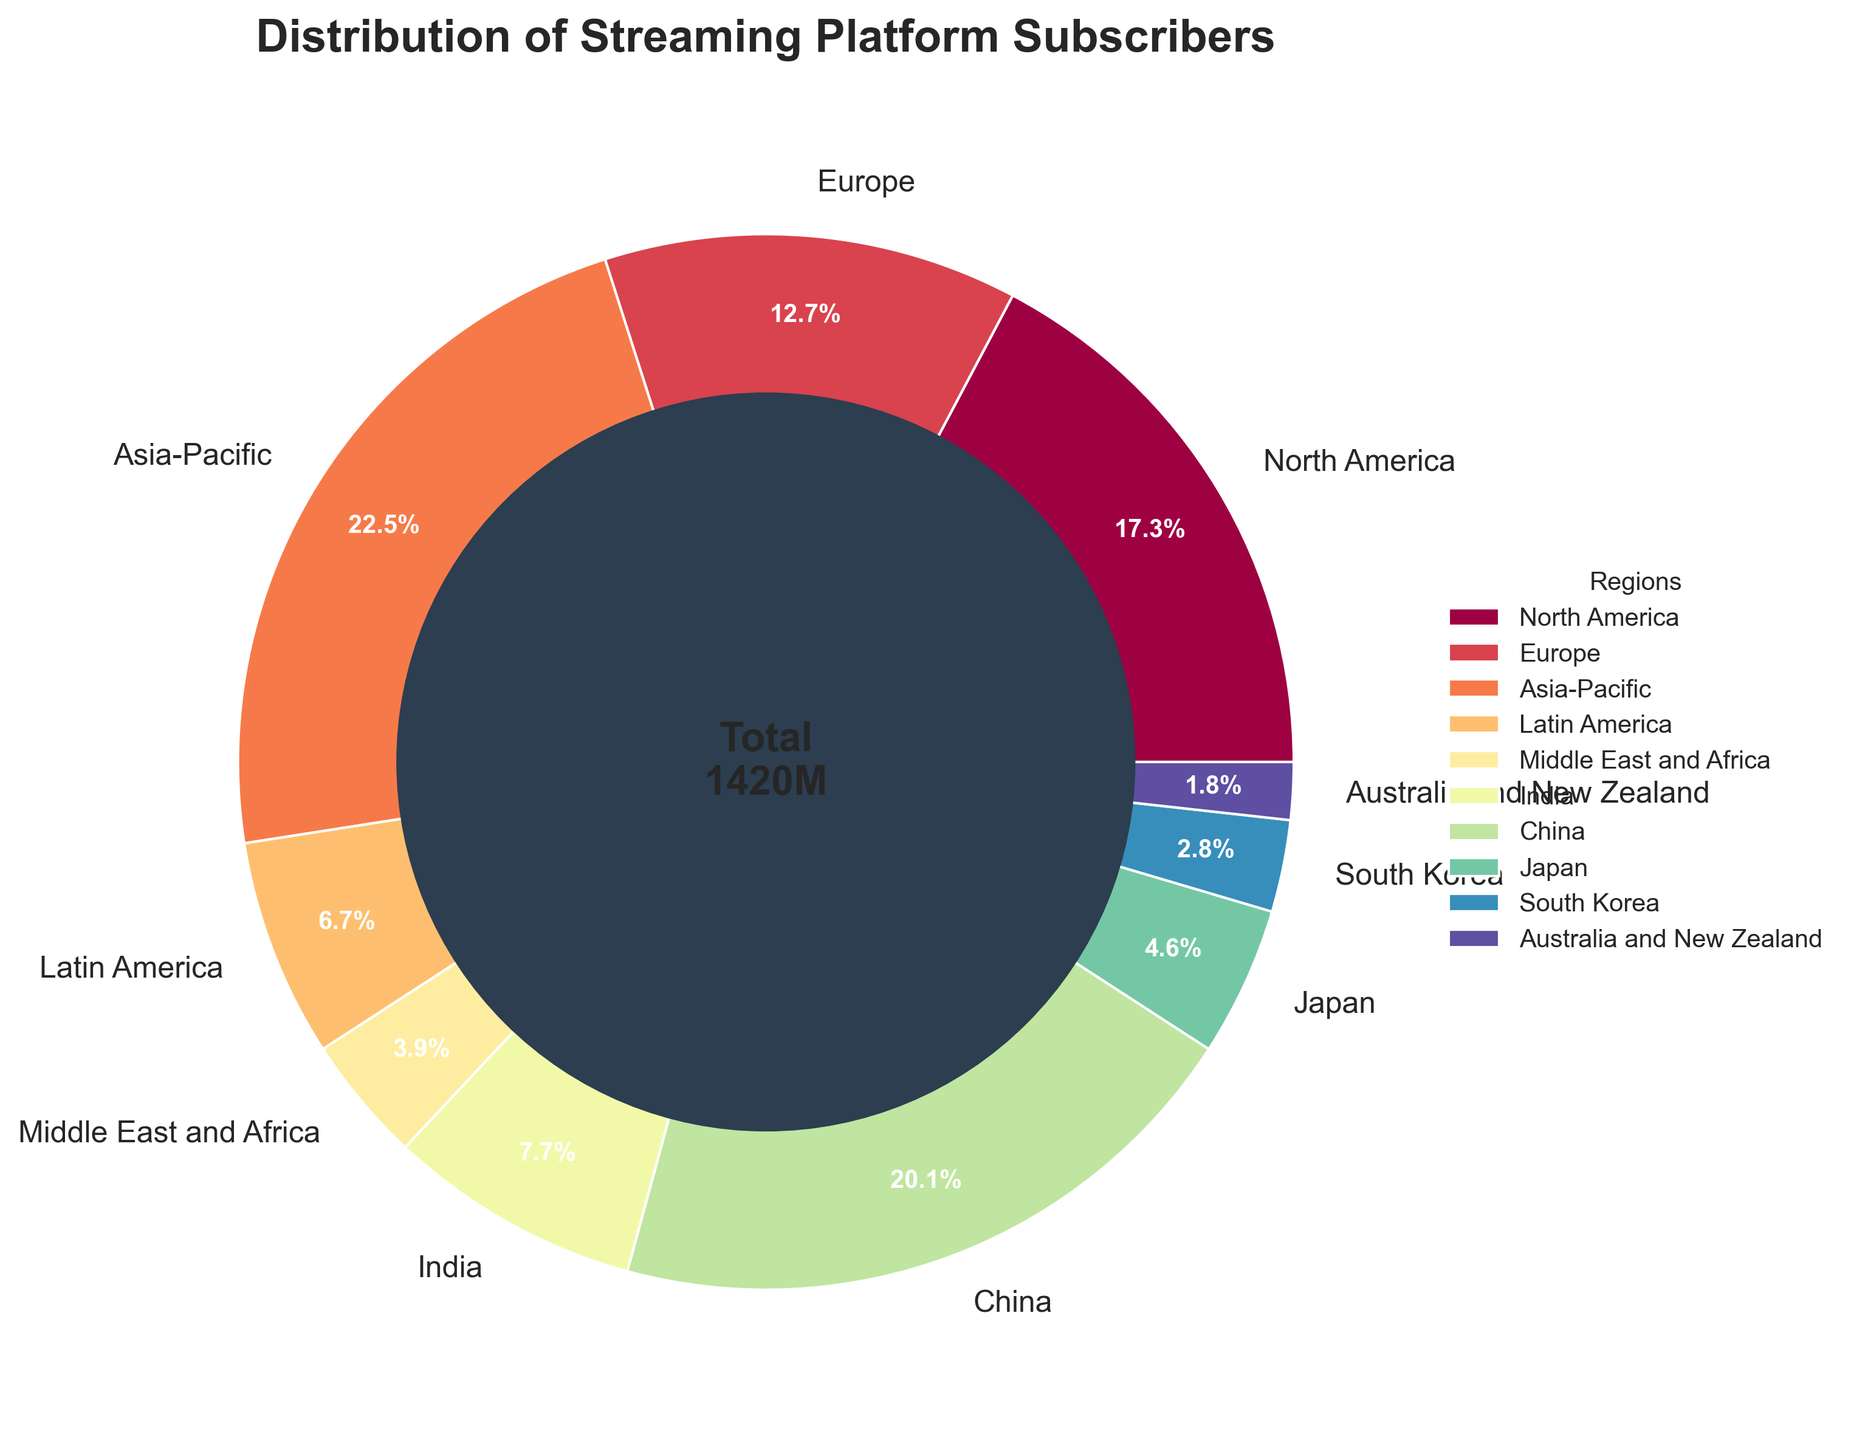What's the total number of streaming platform subscribers in North America and Europe? Summing the subscribers from North America and Europe: 245 million (North America) + 180 million (Europe) = 425 million
Answer: 425 million Which region has more subscribers, China or India? Comparing the subscribers between China and India, China has 285 million while India has 110 million. Hence, China has more subscribers.
Answer: China What percentage of global subscribers is from the Asia-Pacific region? The figure shows 'Asia-Pacific: 320 million subscribers'. The total subscribers are 1420 million. The percentage is (320/1420) * 100 ≈ 22.5%.
Answer: 22.5% Arrange the following regions in decreasing order of subscribers: Middle East and Africa, Japan, South Korea. Checking the figures: Middle East and Africa = 55 million, Japan = 65 million, South Korea = 40 million. So, the order is Japan (65), Middle East and Africa (55), South Korea (40).
Answer: Japan, Middle East and Africa, South Korea What is the ratio of subscribers in Europe to those in Australia and New Zealand? The subscribers in Europe are 180 million and in Australia and New Zealand are 25 million. The ratio is 180:25, which simplifies to 36:5.
Answer: 36:5 How many more subscribers does North America have compared to Latin America? The number of subscribers in North America = 245 million. In Latin America = 95 million. Difference = 245 - 95 = 150 million
Answer: 150 million What is the combined percentage of global subscribers for India and China? The subscribers in India are 110 million and China are 285 million. Total subscribers = 1420 million. Combined percentage = [(110+285)/1420] * 100 ≈ 27.8%.
Answer: 27.8% Which region has the smallest share of subscribers? Looking at the relative sizes of the pie chart slices, Australia and New Zealand has the smallest segment, with 25 million subscribers.
Answer: Australia and New Zealand If the subscribers in Europe increased by 50 million, what would be the new percentage of global subscribers in Europe? New Europe subscribers = 180 + 50 = 230 million. New total subscribers = 1420 + 50 = 1470 million. New percentage = (230/1470) * 100 ≈ 15.6%.
Answer: 15.6% What color represents the Asia-Pacific region in the pie chart? The colors in the pie chart vary; typically, using a color palette like Spectral, Asia-Pacific would be assigned a distinct color. By examining the chart’s legend or corresponding label, the color can be identified.
Answer: [Color The Asia-Pacific region shares in the pie chart] 